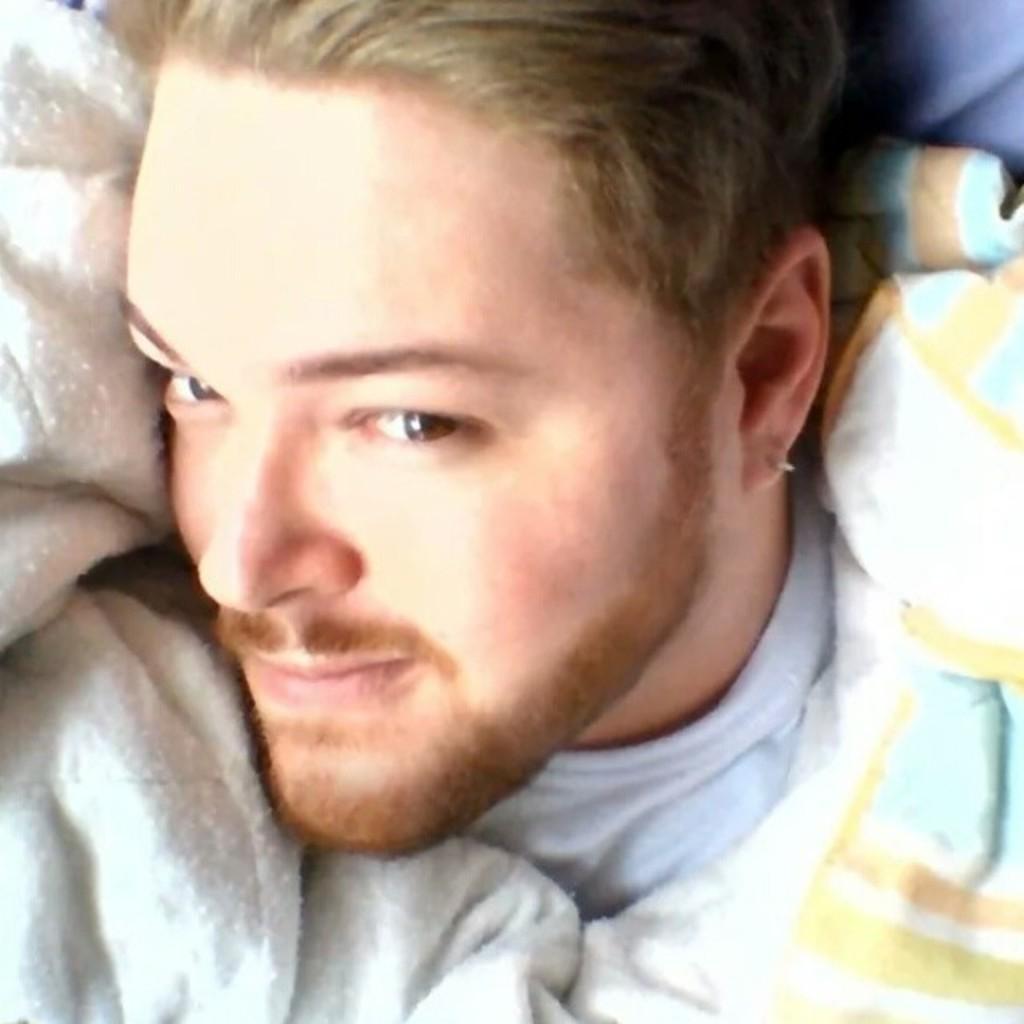Please provide a concise description of this image. In this image we can see a person. And there are clothes on the person. 